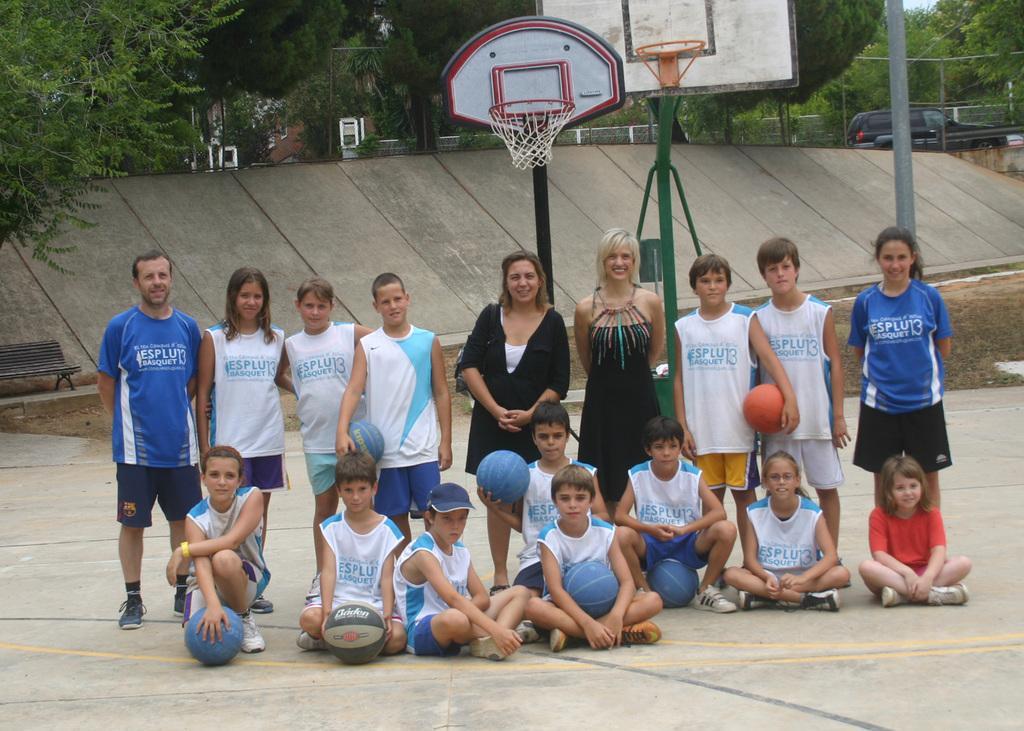Please provide a concise description of this image. In this image we can see persons standing on the floor and some are sitting on the floor and some of them are holding balls in their hands. In the background we can see poles, basketball baskets, motor vehicles on the road, bench and trees. 